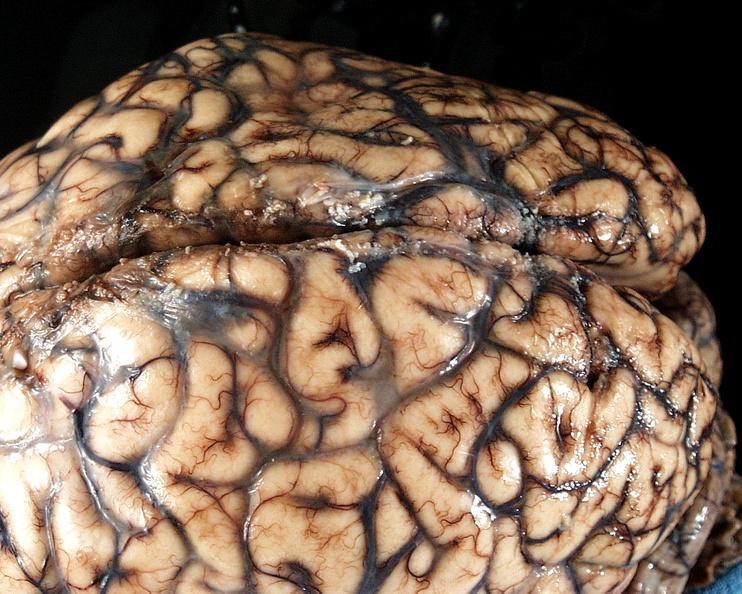does this image show brain, cryptococcal meningitis?
Answer the question using a single word or phrase. Yes 